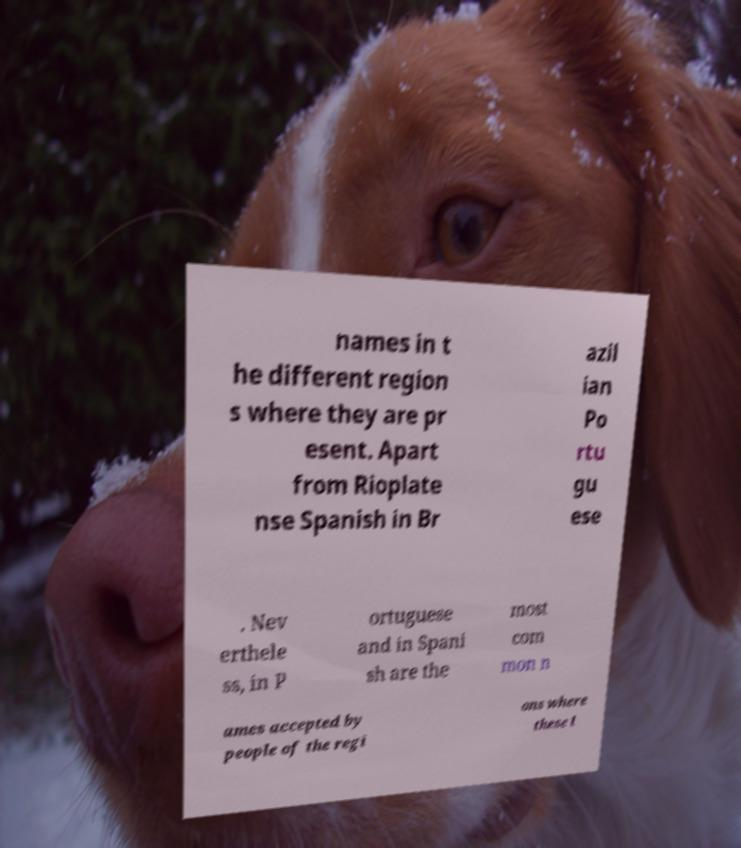What messages or text are displayed in this image? I need them in a readable, typed format. names in t he different region s where they are pr esent. Apart from Rioplate nse Spanish in Br azil ian Po rtu gu ese . Nev erthele ss, in P ortuguese and in Spani sh are the most com mon n ames accepted by people of the regi ons where these l 